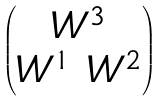Convert formula to latex. <formula><loc_0><loc_0><loc_500><loc_500>\begin{pmatrix} W ^ { 3 } \\ W ^ { 1 } \ W ^ { 2 } \end{pmatrix}</formula> 